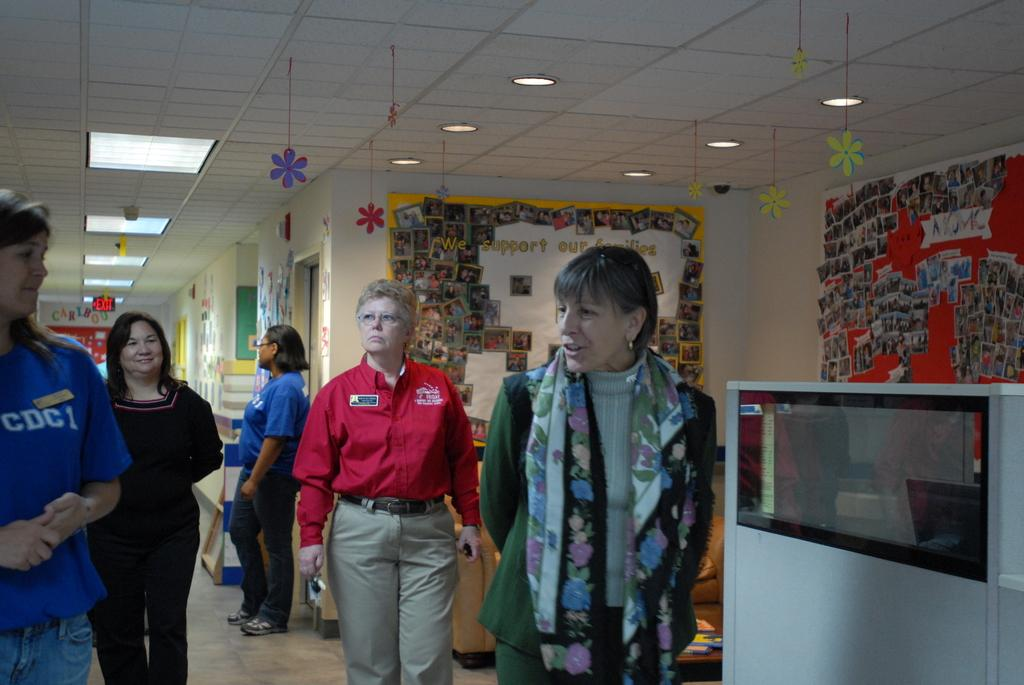<image>
Create a compact narrative representing the image presented. Several women stand in a hallway in front of a bulleting board full of photos with the words "We support our families". 